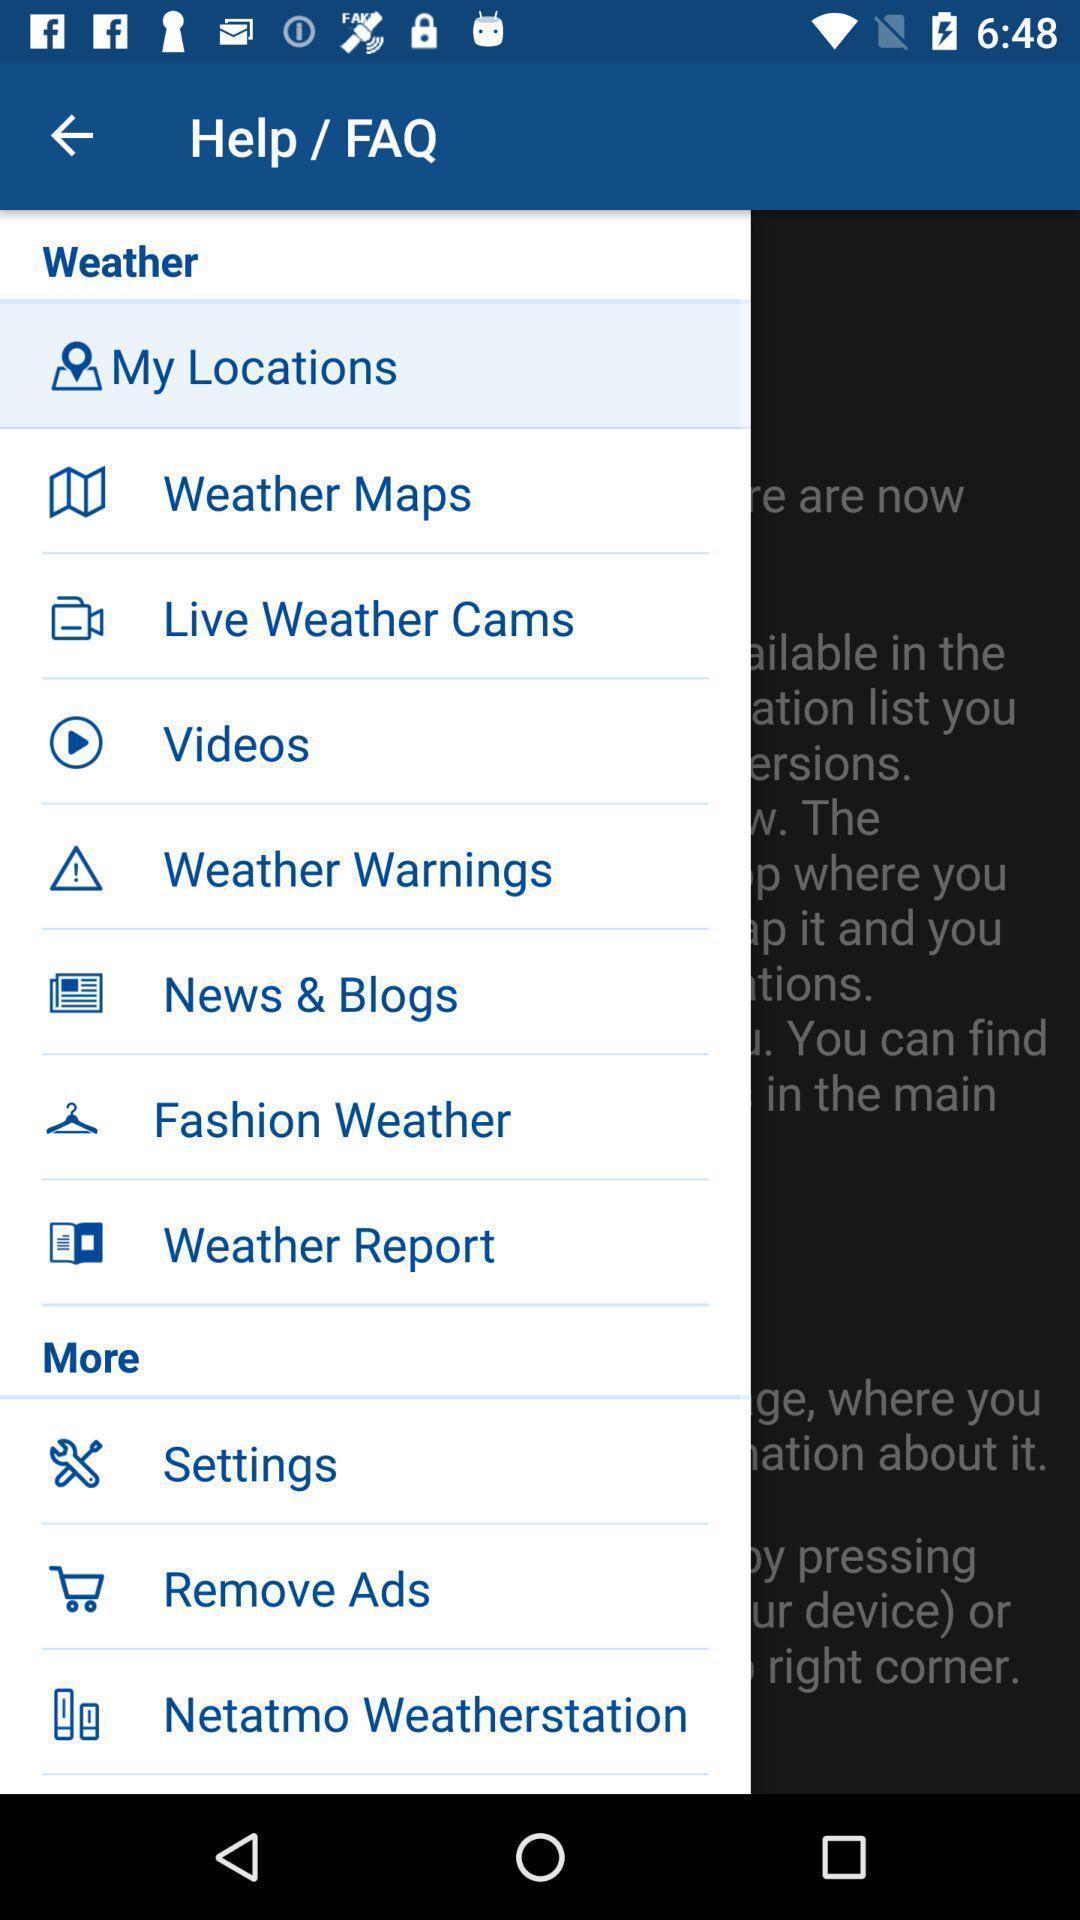Describe the key features of this screenshot. Page showing the options in more menu. 